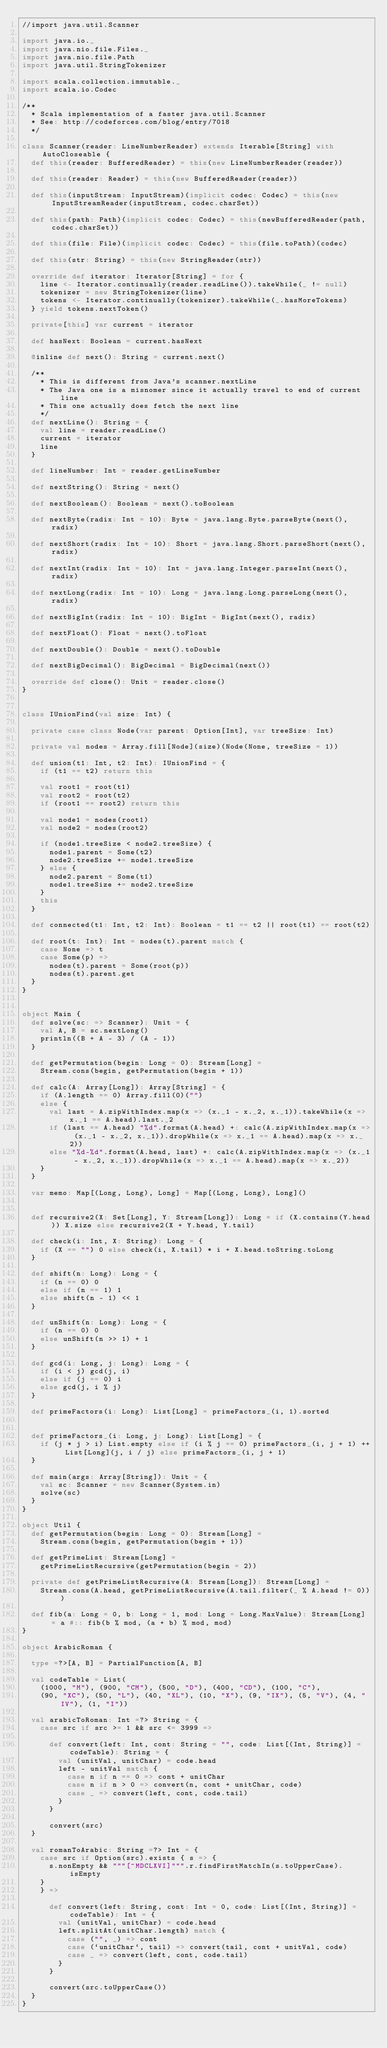Convert code to text. <code><loc_0><loc_0><loc_500><loc_500><_Scala_>//import java.util.Scanner

import java.io._
import java.nio.file.Files._
import java.nio.file.Path
import java.util.StringTokenizer

import scala.collection.immutable._
import scala.io.Codec

/**
  * Scala implementation of a faster java.util.Scanner
  * See: http://codeforces.com/blog/entry/7018
  */

class Scanner(reader: LineNumberReader) extends Iterable[String] with AutoCloseable {
  def this(reader: BufferedReader) = this(new LineNumberReader(reader))

  def this(reader: Reader) = this(new BufferedReader(reader))

  def this(inputStream: InputStream)(implicit codec: Codec) = this(new InputStreamReader(inputStream, codec.charSet))

  def this(path: Path)(implicit codec: Codec) = this(newBufferedReader(path, codec.charSet))

  def this(file: File)(implicit codec: Codec) = this(file.toPath)(codec)

  def this(str: String) = this(new StringReader(str))

  override def iterator: Iterator[String] = for {
    line <- Iterator.continually(reader.readLine()).takeWhile(_ != null)
    tokenizer = new StringTokenizer(line)
    tokens <- Iterator.continually(tokenizer).takeWhile(_.hasMoreTokens)
  } yield tokens.nextToken()

  private[this] var current = iterator

  def hasNext: Boolean = current.hasNext

  @inline def next(): String = current.next()

  /**
    * This is different from Java's scanner.nextLine
    * The Java one is a misnomer since it actually travel to end of current line
    * This one actually does fetch the next line
    */
  def nextLine(): String = {
    val line = reader.readLine()
    current = iterator
    line
  }

  def lineNumber: Int = reader.getLineNumber

  def nextString(): String = next()

  def nextBoolean(): Boolean = next().toBoolean

  def nextByte(radix: Int = 10): Byte = java.lang.Byte.parseByte(next(), radix)

  def nextShort(radix: Int = 10): Short = java.lang.Short.parseShort(next(), radix)

  def nextInt(radix: Int = 10): Int = java.lang.Integer.parseInt(next(), radix)

  def nextLong(radix: Int = 10): Long = java.lang.Long.parseLong(next(), radix)

  def nextBigInt(radix: Int = 10): BigInt = BigInt(next(), radix)

  def nextFloat(): Float = next().toFloat

  def nextDouble(): Double = next().toDouble

  def nextBigDecimal(): BigDecimal = BigDecimal(next())

  override def close(): Unit = reader.close()
}


class IUnionFind(val size: Int) {

  private case class Node(var parent: Option[Int], var treeSize: Int)

  private val nodes = Array.fill[Node](size)(Node(None, treeSize = 1))

  def union(t1: Int, t2: Int): IUnionFind = {
    if (t1 == t2) return this

    val root1 = root(t1)
    val root2 = root(t2)
    if (root1 == root2) return this

    val node1 = nodes(root1)
    val node2 = nodes(root2)

    if (node1.treeSize < node2.treeSize) {
      node1.parent = Some(t2)
      node2.treeSize += node1.treeSize
    } else {
      node2.parent = Some(t1)
      node1.treeSize += node2.treeSize
    }
    this
  }

  def connected(t1: Int, t2: Int): Boolean = t1 == t2 || root(t1) == root(t2)

  def root(t: Int): Int = nodes(t).parent match {
    case None => t
    case Some(p) =>
      nodes(t).parent = Some(root(p))
      nodes(t).parent.get
  }
}


object Main {
  def solve(sc: => Scanner): Unit = {
    val A, B = sc.nextLong()
    println((B + A - 3) / (A - 1))
  }

  def getPermutation(begin: Long = 0): Stream[Long] =
    Stream.cons(begin, getPermutation(begin + 1))

  def calc(A: Array[Long]): Array[String] = {
    if (A.length == 0) Array.fill(0)("")
    else {
      val last = A.zipWithIndex.map(x => (x._1 - x._2, x._1)).takeWhile(x => x._1 == A.head).last._2
      if (last == A.head) "%d".format(A.head) +: calc(A.zipWithIndex.map(x => (x._1 - x._2, x._1)).dropWhile(x => x._1 == A.head).map(x => x._2))
      else "%d-%d".format(A.head, last) +: calc(A.zipWithIndex.map(x => (x._1 - x._2, x._1)).dropWhile(x => x._1 == A.head).map(x => x._2))
    }
  }

  var memo: Map[(Long, Long), Long] = Map[(Long, Long), Long]()


  def recursive2(X: Set[Long], Y: Stream[Long]): Long = if (X.contains(Y.head)) X.size else recursive2(X + Y.head, Y.tail)

  def check(i: Int, X: String): Long = {
    if (X == "") 0 else check(i, X.tail) * i + X.head.toString.toLong
  }

  def shift(n: Long): Long = {
    if (n == 0) 0
    else if (n == 1) 1
    else shift(n - 1) << 1
  }

  def unShift(n: Long): Long = {
    if (n == 0) 0
    else unShift(n >> 1) + 1
  }

  def gcd(i: Long, j: Long): Long = {
    if (i < j) gcd(j, i)
    else if (j == 0) i
    else gcd(j, i % j)
  }

  def primeFactors(i: Long): List[Long] = primeFactors_(i, 1).sorted


  def primeFactors_(i: Long, j: Long): List[Long] = {
    if (j * j > i) List.empty else if (i % j == 0) primeFactors_(i, j + 1) ++ List[Long](j, i / j) else primeFactors_(i, j + 1)
  }

  def main(args: Array[String]): Unit = {
    val sc: Scanner = new Scanner(System.in)
    solve(sc)
  }
}

object Util {
  def getPermutation(begin: Long = 0): Stream[Long] =
    Stream.cons(begin, getPermutation(begin + 1))

  def getPrimeList: Stream[Long] =
    getPrimeListRecursive(getPermutation(begin = 2))

  private def getPrimeListRecursive(A: Stream[Long]): Stream[Long] =
    Stream.cons(A.head, getPrimeListRecursive(A.tail.filter(_ % A.head != 0)))

  def fib(a: Long = 0, b: Long = 1, mod: Long = Long.MaxValue): Stream[Long] = a #:: fib(b % mod, (a + b) % mod, mod)
}

object ArabicRoman {

  type =?>[A, B] = PartialFunction[A, B]

  val codeTable = List(
    (1000, "M"), (900, "CM"), (500, "D"), (400, "CD"), (100, "C"),
    (90, "XC"), (50, "L"), (40, "XL"), (10, "X"), (9, "IX"), (5, "V"), (4, "IV"), (1, "I"))

  val arabicToRoman: Int =?> String = {
    case src if src >= 1 && src <= 3999 =>

      def convert(left: Int, cont: String = "", code: List[(Int, String)] = codeTable): String = {
        val (unitVal, unitChar) = code.head
        left - unitVal match {
          case n if n == 0 => cont + unitChar
          case n if n > 0 => convert(n, cont + unitChar, code)
          case _ => convert(left, cont, code.tail)
        }
      }

      convert(src)
  }

  val romanToArabic: String =?> Int = {
    case src if Option(src).exists { s => {
      s.nonEmpty && """[^MDCLXVI]""".r.findFirstMatchIn(s.toUpperCase).isEmpty
    }
    } =>

      def convert(left: String, cont: Int = 0, code: List[(Int, String)] = codeTable): Int = {
        val (unitVal, unitChar) = code.head
        left.splitAt(unitChar.length) match {
          case ("", _) => cont
          case (`unitChar`, tail) => convert(tail, cont + unitVal, code)
          case _ => convert(left, cont, code.tail)
        }
      }

      convert(src.toUpperCase())
  }
}
</code> 